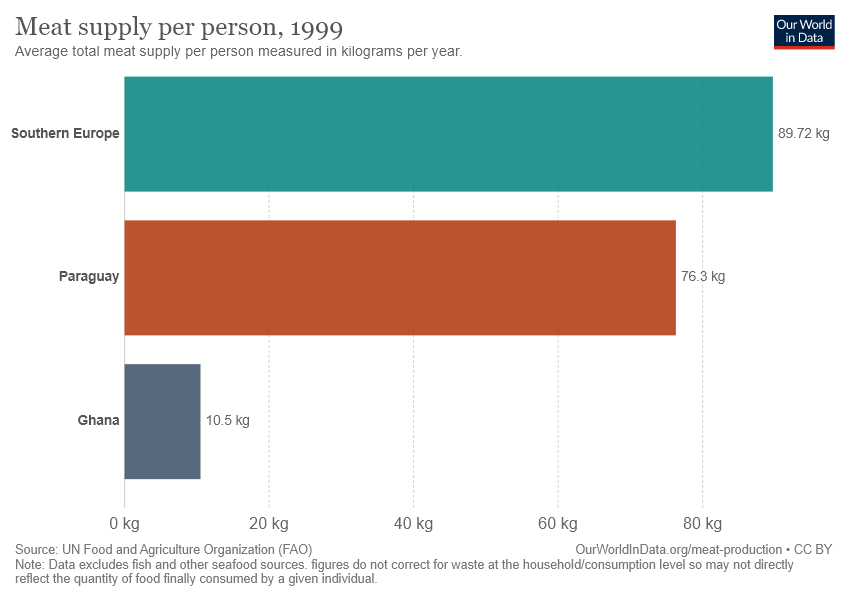What is average total meat supply per person in Ghana?
 10.5 